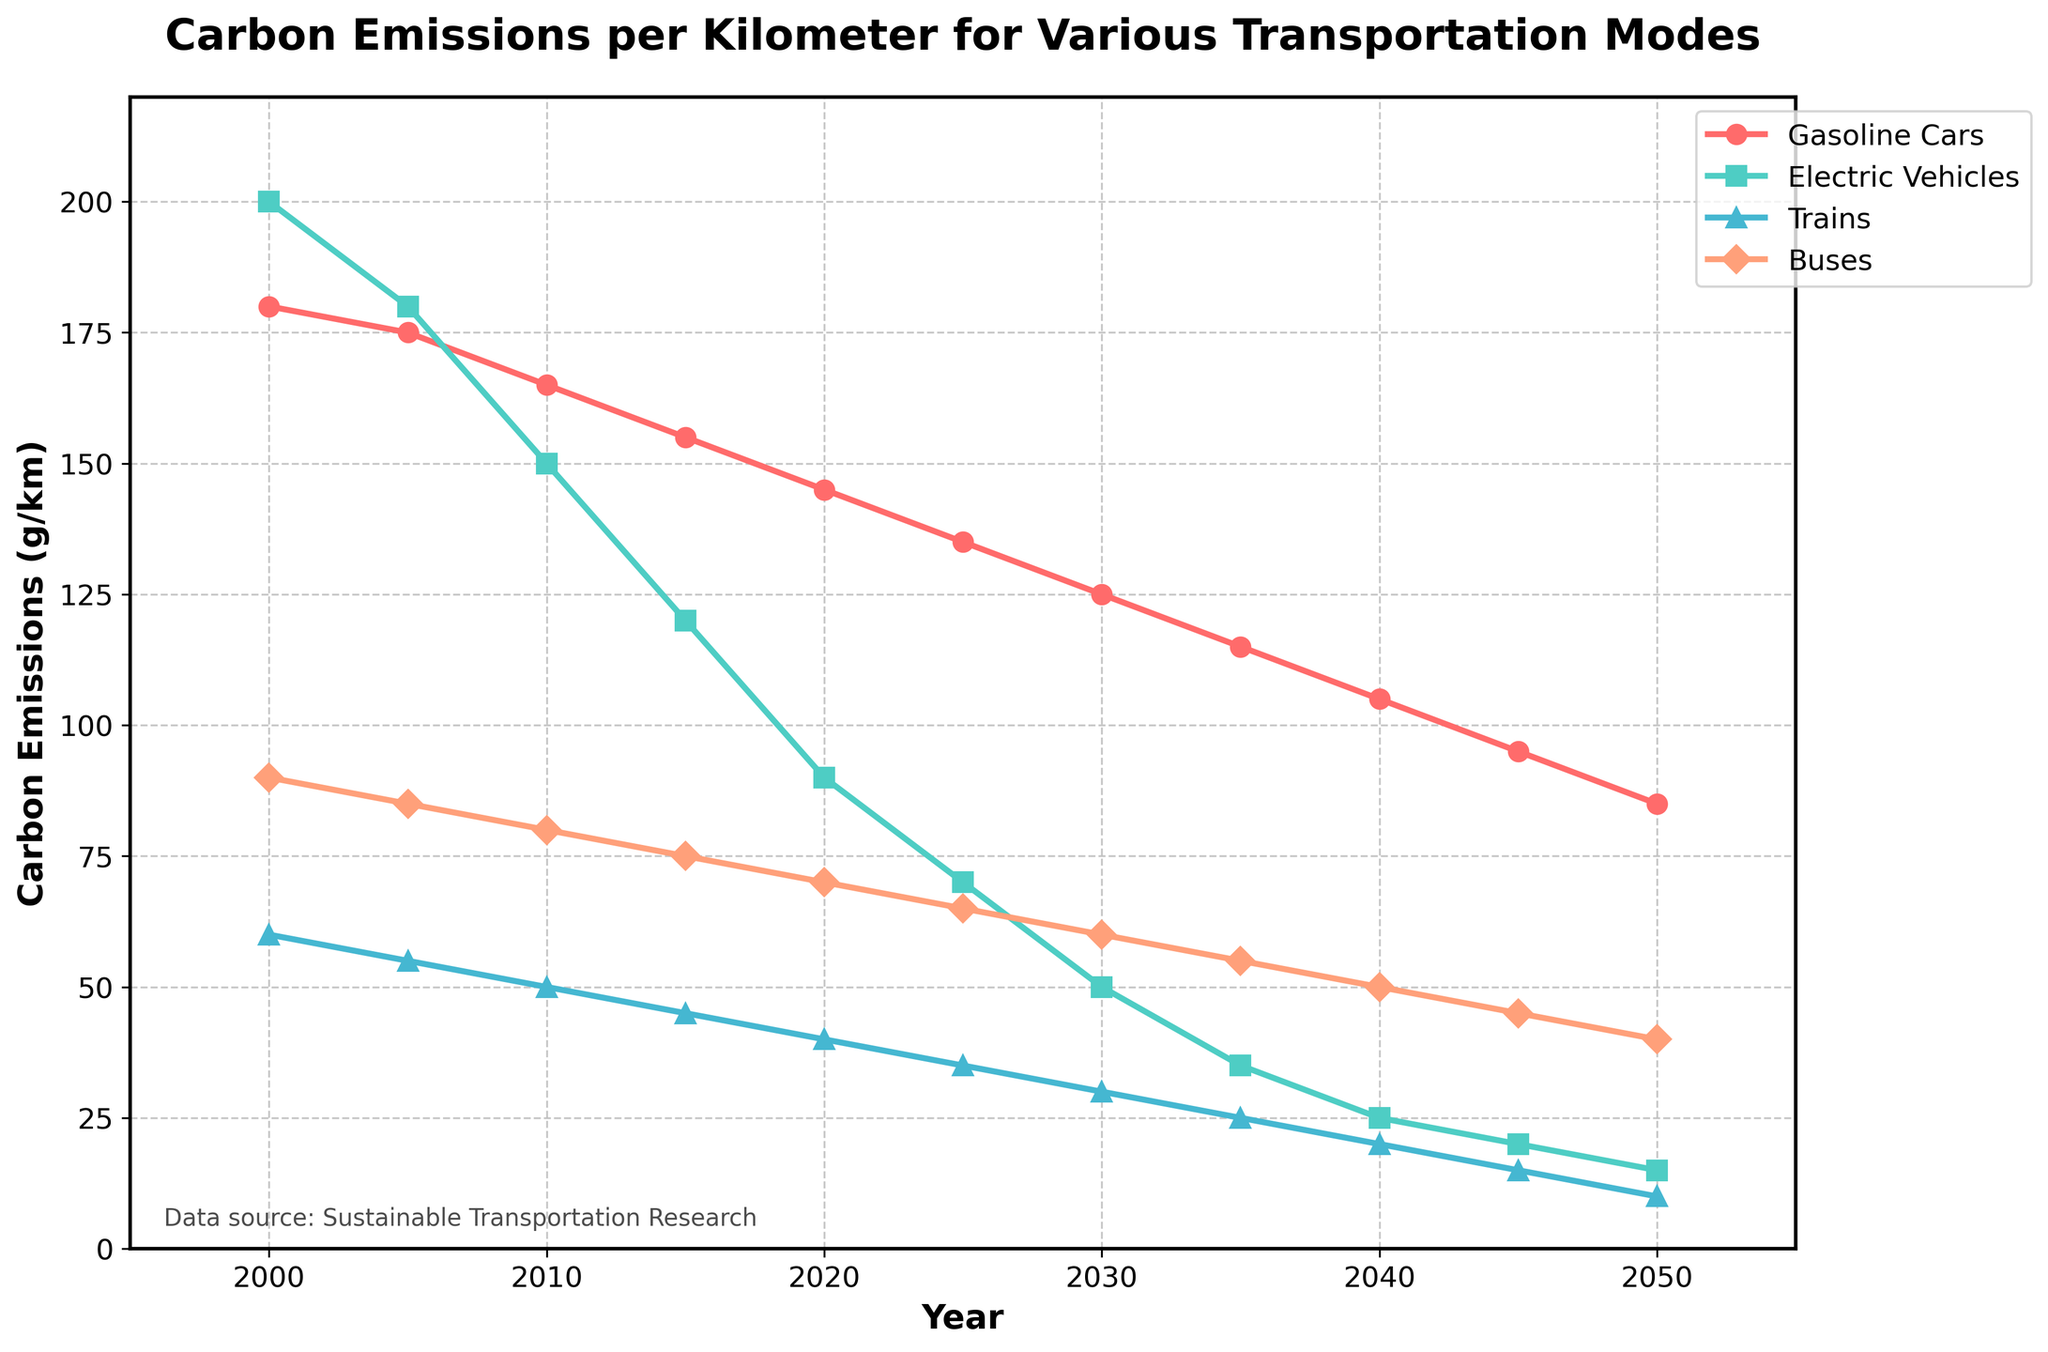Which transportation mode has the highest carbon emissions per kilometer in the year 2000? Observing the line chart, we see that Electric Vehicles have the highest carbon emissions per km in the year 2000.
Answer: Electric Vehicles By how much did the carbon emissions of Electric Vehicles decrease from 2000 to 2050? Looking at the graph, Electric Vehicles' emissions decreased from 200 g/km in 2000 to 15 g/km in 2050. Thus, the decrease is 200 - 15 = 185 g/km.
Answer: 185 g/km Which transportation mode shows the steepest decline in carbon emissions between 2020 and 2030? Analyzing the slopes of the lines in the chart between 2020 and 2030, Electric Vehicles show the steepest decline in emissions during this period.
Answer: Electric Vehicles In 2040, what is the difference in carbon emissions between Gasoline Cars and Buses? From the chart, Gasoline Cars have 105 g/km and Buses have 50 g/km in 2040. So, the difference is 105 - 50 = 55 g/km.
Answer: 55 g/km Between 2005 and 2015, which transportation mode reduced its carbon emissions the most, and by how much? Using the data, Gasoline Cars went from 175 g/km to 155 g/km (a reduction of 20 g/km), Electric Vehicles from 180 to 120 g/km (60 g/km), Trains from 55 to 45 g/km (10 g/km), and Buses from 85 to 75 g/km (10 g/km). Electric Vehicles reduced the most, by 60 g/km.
Answer: Electric Vehicles, 60 g/km How many years did it take for the carbon emissions of Buses to halve from their 2000 value? In 2000, Buses’ emissions are 90 g/km. Halving this is 45 g/km. Checking the chart, Buses reach 45 g/km in 2045. So, it took 2045 - 2000 = 45 years.
Answer: 45 years What is the average carbon emissions per kilometer for Trains in the years 2000, 2025, and 2050? From the chart, Trains have emissions of 60 g/km in 2000, 35 g/km in 2025, and 10 g/km in 2050. The average is (60 + 35 + 10)/3 = 35 g/km.
Answer: 35 g/km Among all transportation modes, which has the lowest emissions in 2050? At the end of the timeline in 2050, Trains have the lowest emissions at 10 g/km.
Answer: Trains By what percentage did the carbon emissions of Gasoline Cars decrease from 2000 to 2050? Carbon emissions of Gasoline Cars decreased from 180 g/km in 2000 to 85 g/km in 2050. The percentage decrease is ((180 - 85) / 180) * 100 = 52.78%.
Answer: 52.78% 